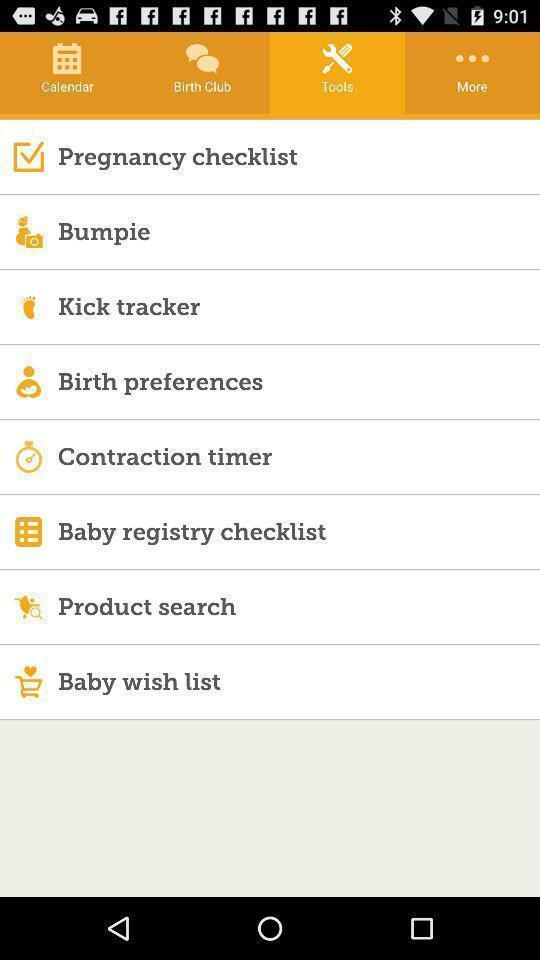Tell me about the visual elements in this screen capture. Page showing list of tools on a health care app. 